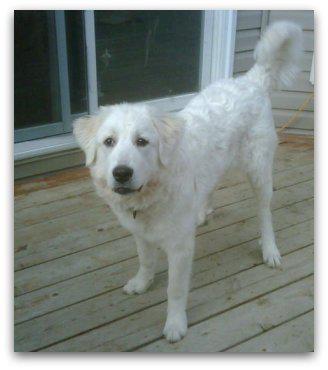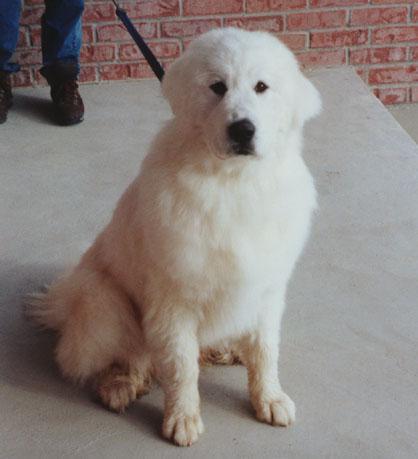The first image is the image on the left, the second image is the image on the right. Analyze the images presented: Is the assertion "There is a white dog in each photo looking straight ahead enjoying it's time outside." valid? Answer yes or no. Yes. The first image is the image on the left, the second image is the image on the right. Analyze the images presented: Is the assertion "in both pairs the dogs are on a natural outdoor surface" valid? Answer yes or no. No. 